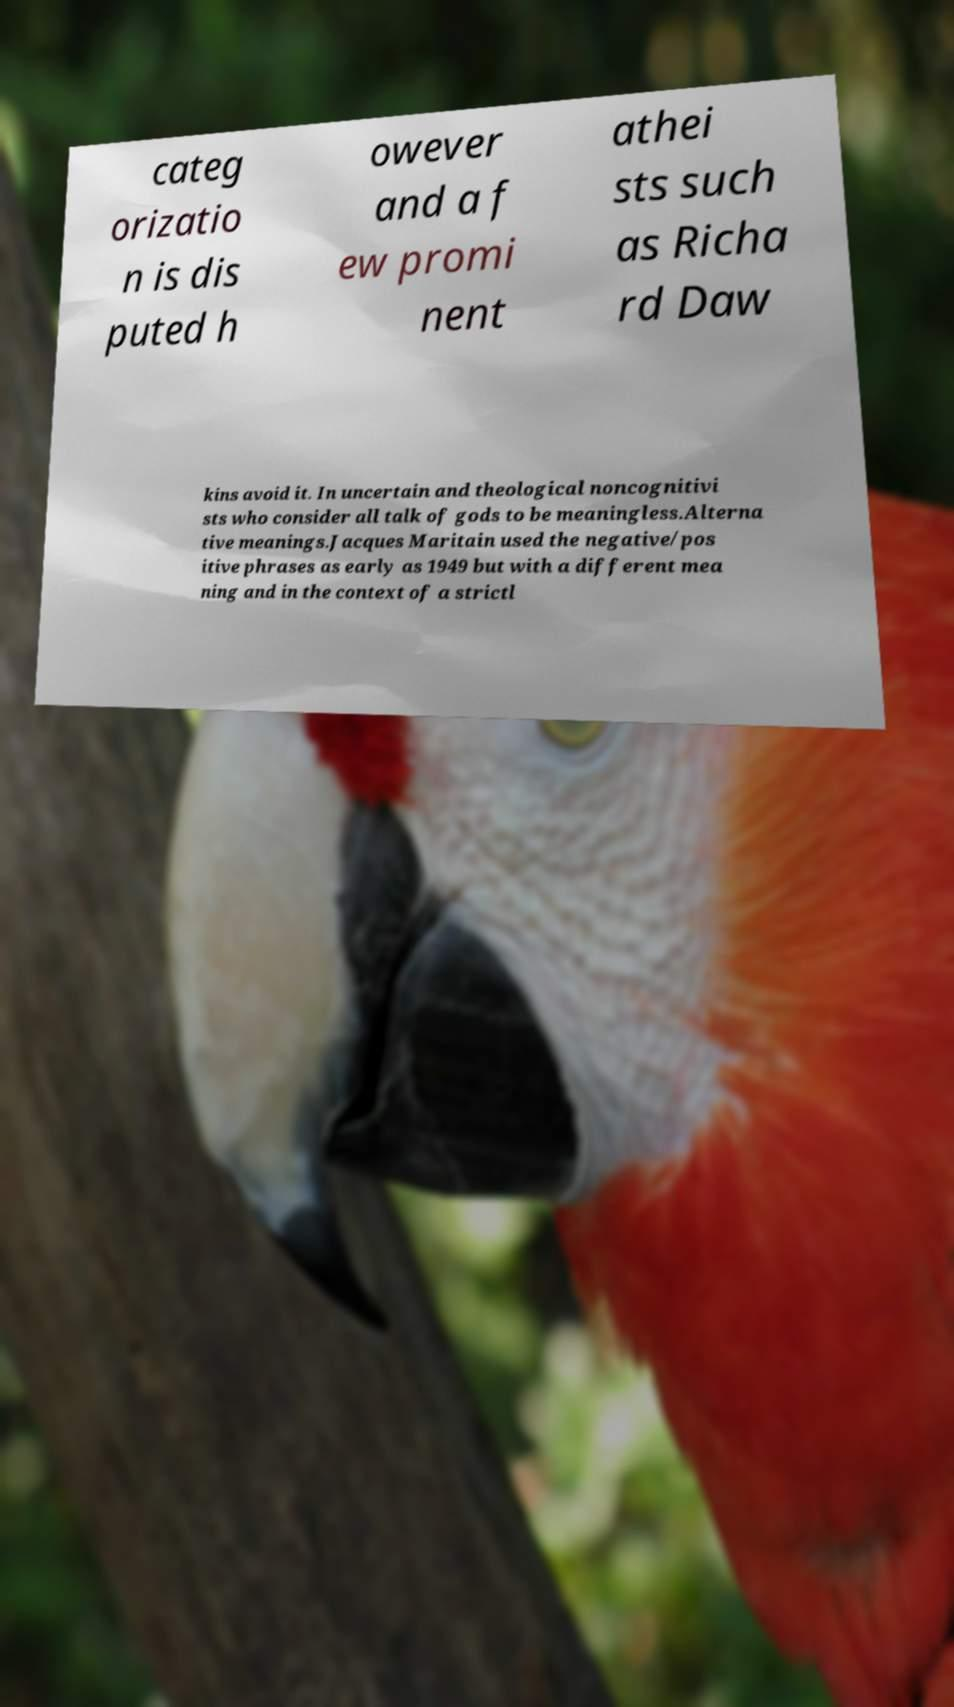Please identify and transcribe the text found in this image. categ orizatio n is dis puted h owever and a f ew promi nent athei sts such as Richa rd Daw kins avoid it. In uncertain and theological noncognitivi sts who consider all talk of gods to be meaningless.Alterna tive meanings.Jacques Maritain used the negative/pos itive phrases as early as 1949 but with a different mea ning and in the context of a strictl 